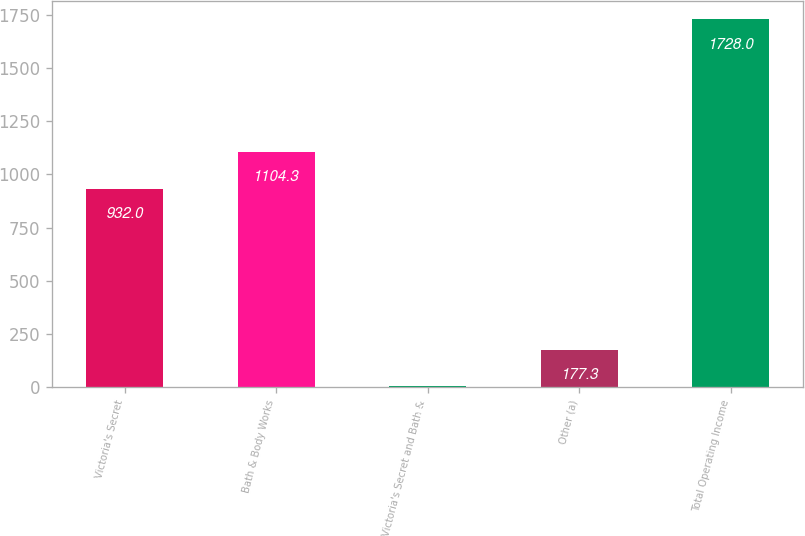<chart> <loc_0><loc_0><loc_500><loc_500><bar_chart><fcel>Victoria's Secret<fcel>Bath & Body Works<fcel>Victoria's Secret and Bath &<fcel>Other (a)<fcel>Total Operating Income<nl><fcel>932<fcel>1104.3<fcel>5<fcel>177.3<fcel>1728<nl></chart> 